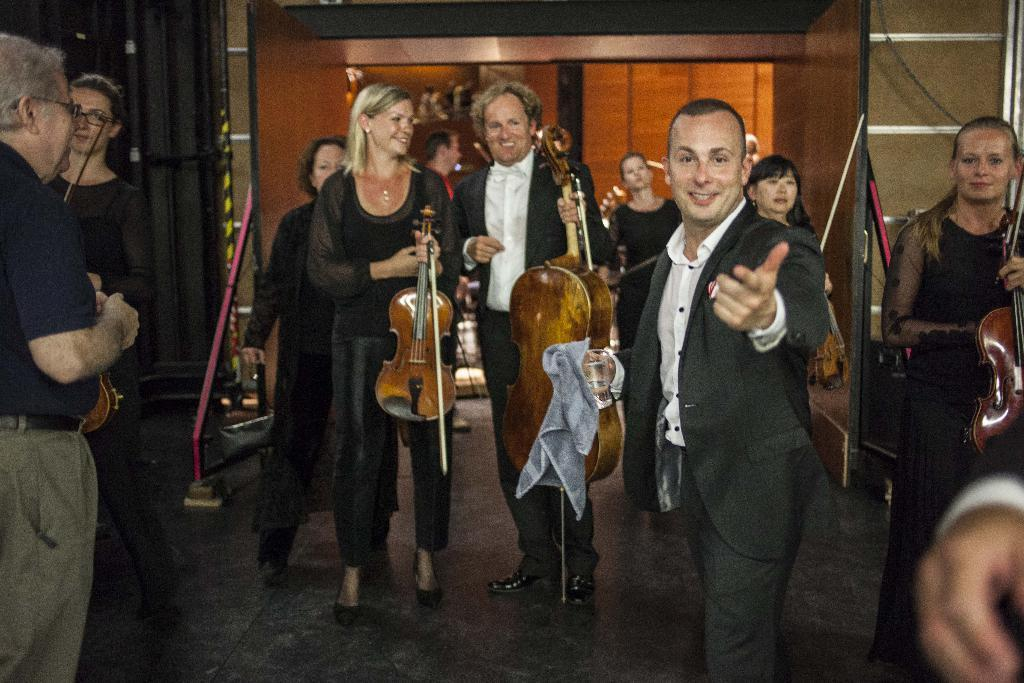Who is present in the image? There are people in the image. What are the people doing in the image? The people are on a path, and some of them are holding musical instruments. What is the emotional state of some of the people in the image? Some of the people are smiling. What type of tub can be seen in the image? There is no tub present in the image. 